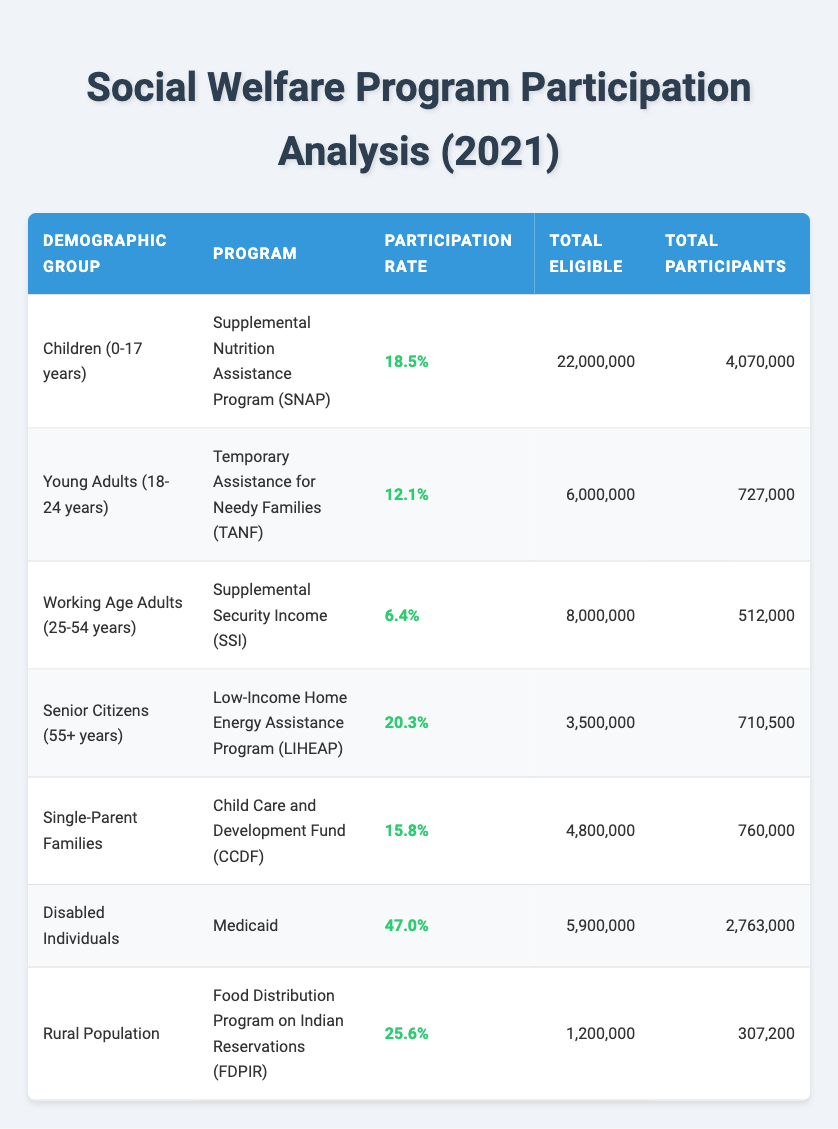What is the participation rate of Disabled Individuals in the Medicaid program? According to the table, the participation rate for Disabled Individuals in Medicaid is explicitly listed as 47.0%.
Answer: 47.0% How many total eligible individuals are there in the Food Distribution Program on Indian Reservations for the Rural Population? The table states that the total eligible individuals in the Food Distribution Program on Indian Reservations for the Rural Population is 1,200,000.
Answer: 1,200,000 What is the average participation rate for Children (0-17 years) and Senior Citizens (55+ years) in their respective programs? The participation rate for Children in SNAP is 18.5%, and for Senior Citizens in LIHEAP is 20.3%. The average participation rate is (18.5 + 20.3) / 2 = 19.4%.
Answer: 19.4% Is the participation rate of Working Age Adults (25-54 years) in Supplemental Security Income greater than that of Young Adults (18-24 years) in Temporary Assistance for Needy Families? The participation rate for Working Age Adults is 6.4%, while for Young Adults it is 12.1%. Since 6.4% is less than 12.1%, the statement is false.
Answer: No What is the total number of participants in the Child Care and Development Fund for Single-Parent Families? The table indicates that the total number of participants in the Child Care and Development Fund for Single-Parent Families is 760,000.
Answer: 760,000 If you combine the total participants of the SNAP program for Children and the LIHEAP program for Senior Citizens, what is the total? The total participants for Children in SNAP is 4,070,000, and for Seniors in LIHEAP, it is 710,500. Adding these together gives 4,070,000 + 710,500 = 4,780,500.
Answer: 4,780,500 Are there more eligible individuals in the Supplemental Security Income program or the Temporary Assistance for Needy Families program? The total eligible individuals in Supplemental Security Income is 8,000,000, while in Temporary Assistance for Needy Families, it is 6,000,000. Since 8,000,000 is greater than 6,000,000, the statement is true.
Answer: Yes What percentage of eligible Single-Parent Families participated in the Child Care and Development Fund? The participation rate for Single-Parent Families in the Child Care and Development Fund is given as 15.8%, confirming their percentage of participation among the eligible group.
Answer: 15.8% 